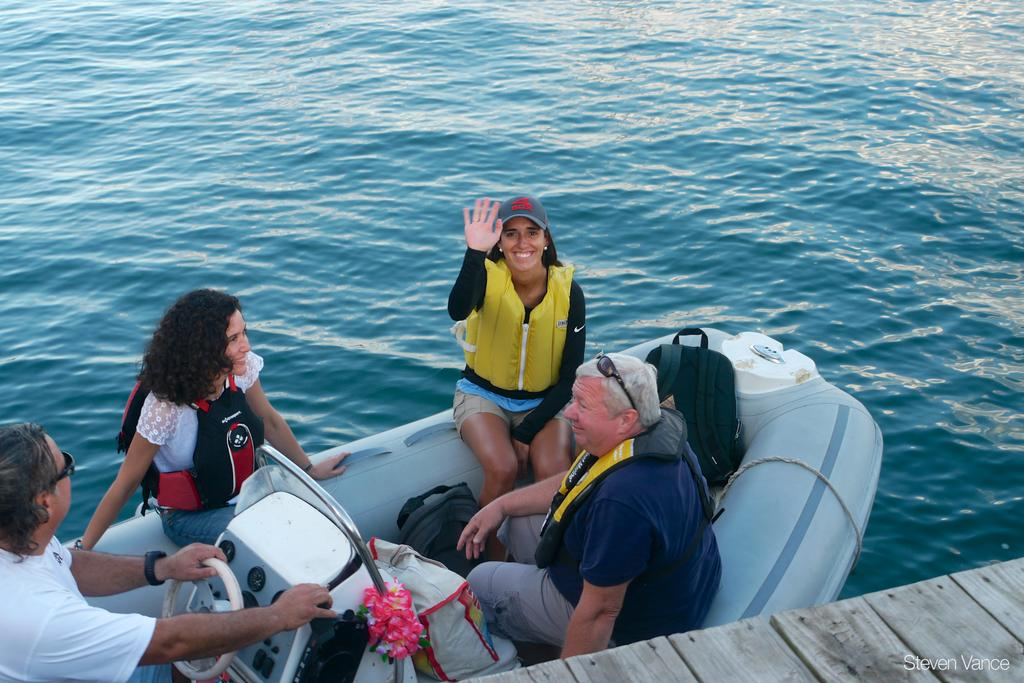What type of structure is present in the image? There is a wooden platform in the image. What are the people in the image doing? People are in a boat on the wooden platform. What can be seen in the background of the image? There is water visible in the background of the image. Where is the text located in the image? The text is in the bottom right corner of the image. What type of parcel can be seen floating in the water in the image? There is no parcel visible in the water in the image. What color is the bottle on the wooden platform in the image? There is no bottle present on the wooden platform in the image. 